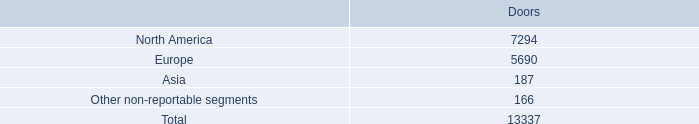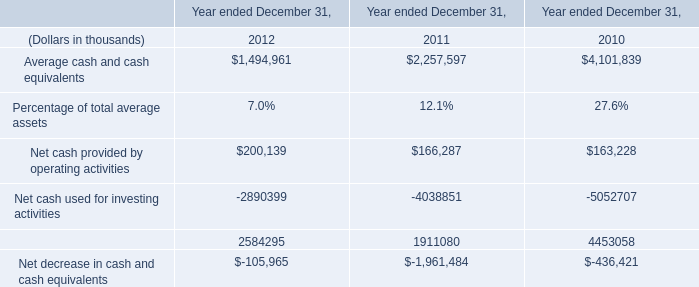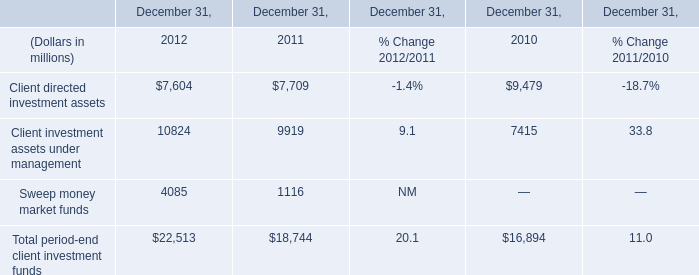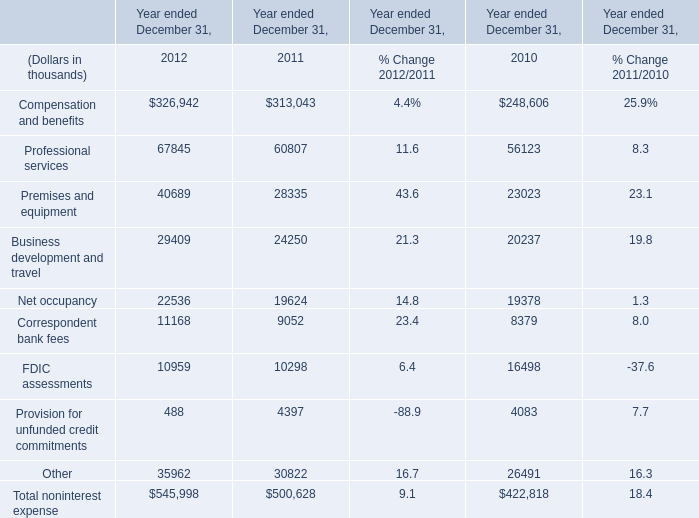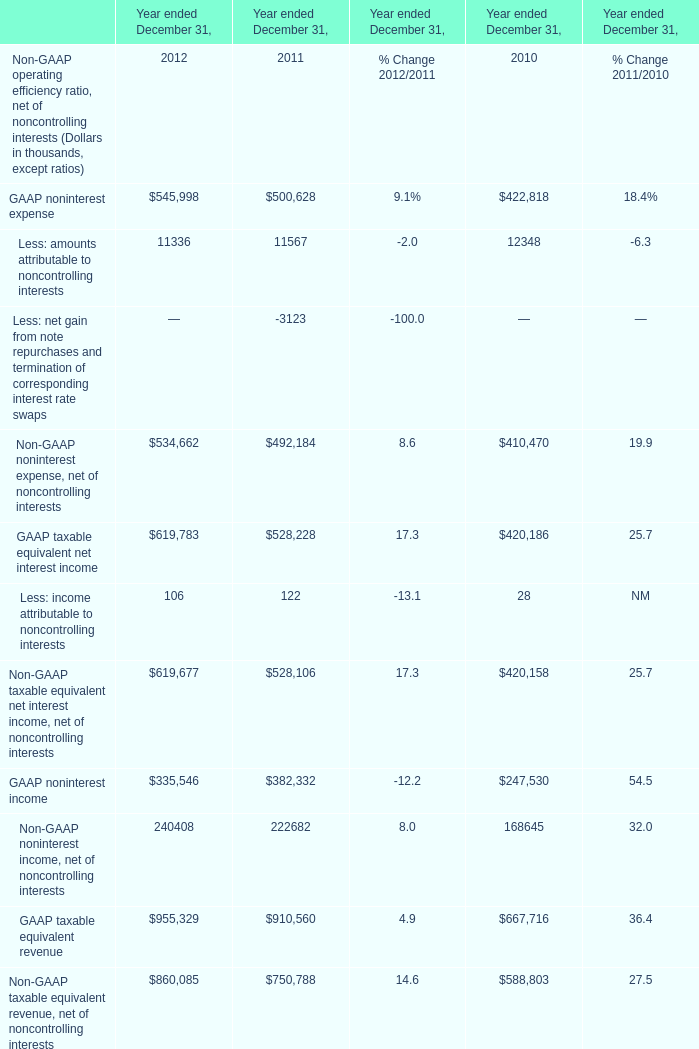What's the average of Compensation and benefits of Year ended December 31, 2010, and GAAP noninterest income of Year ended December 31, 2011 ? 
Computations: ((248606.0 + 382332.0) / 2)
Answer: 315469.0. 